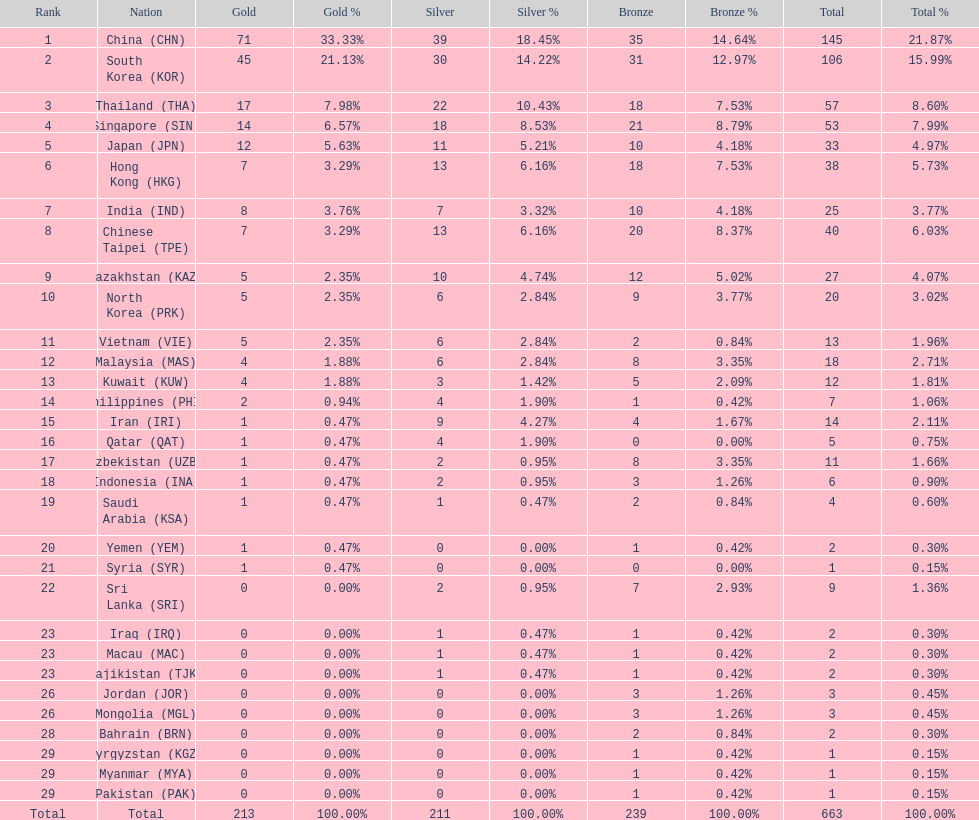What was the total of medals iran gained? 14. 